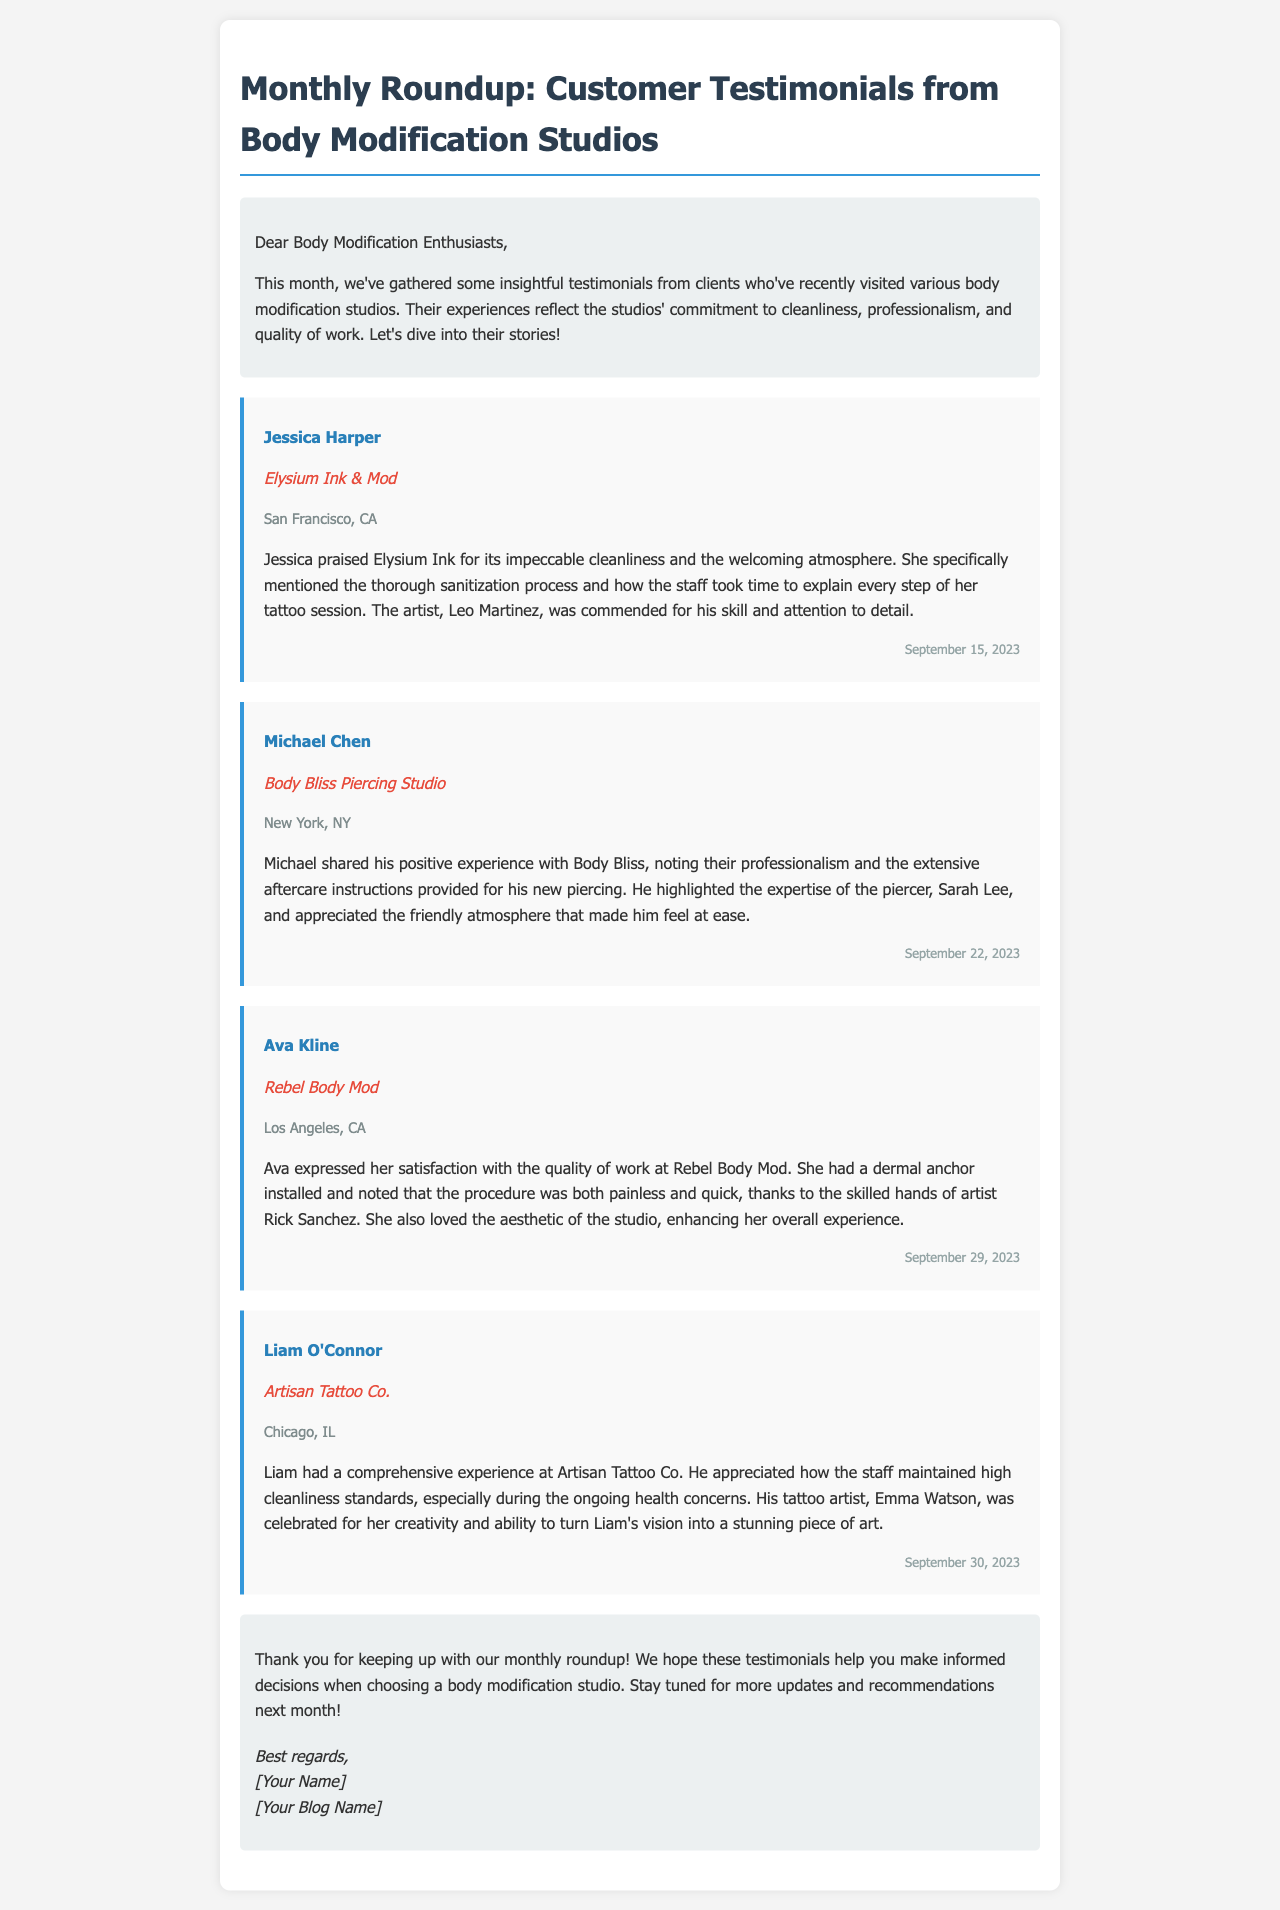What is the name of the first customer featured? The first customer's name, as stated in the document, is Jessica Harper.
Answer: Jessica Harper What city is Elysium Ink & Mod located in? The document indicates that Elysium Ink & Mod is located in San Francisco, CA.
Answer: San Francisco, CA Who is the artist mentioned in Jessica Harper's testimonial? The testimonial for Jessica specifies that the artist's name is Leo Martinez.
Answer: Leo Martinez What service did Ava Kline receive at Rebel Body Mod? Ava Kline received a dermal anchor installation, as mentioned in her testimonial.
Answer: Dermal anchor Which studio did Liam O'Connor visit? Liam O'Connor's testimonial states that he visited Artisan Tattoo Co.
Answer: Artisan Tattoo Co How did Michael Chen describe the atmosphere at Body Bliss Piercing Studio? Michael Chen described the atmosphere as friendly, according to his experience shared in the document.
Answer: Friendly On what date did Jessica Harper visit Elysium Ink & Mod? The date noted for Jessica Harper's visit is September 15, 2023.
Answer: September 15, 2023 What is the central theme of the email? The document summarizes customer testimonials focusing on cleanliness, professionalism, and quality of work at body modification studios.
Answer: Customer testimonials What feedback did Liam O'Connor give about his tattoo artist? Liam O'Connor appreciated his artist's creativity and ability to bring his vision to life.
Answer: Creativity and vision 